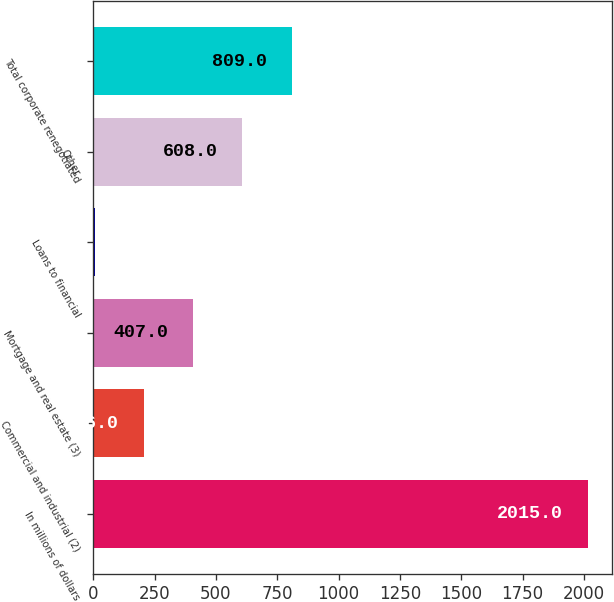Convert chart to OTSL. <chart><loc_0><loc_0><loc_500><loc_500><bar_chart><fcel>In millions of dollars<fcel>Commercial and industrial (2)<fcel>Mortgage and real estate (3)<fcel>Loans to financial<fcel>Other<fcel>Total corporate renegotiated<nl><fcel>2015<fcel>206<fcel>407<fcel>5<fcel>608<fcel>809<nl></chart> 